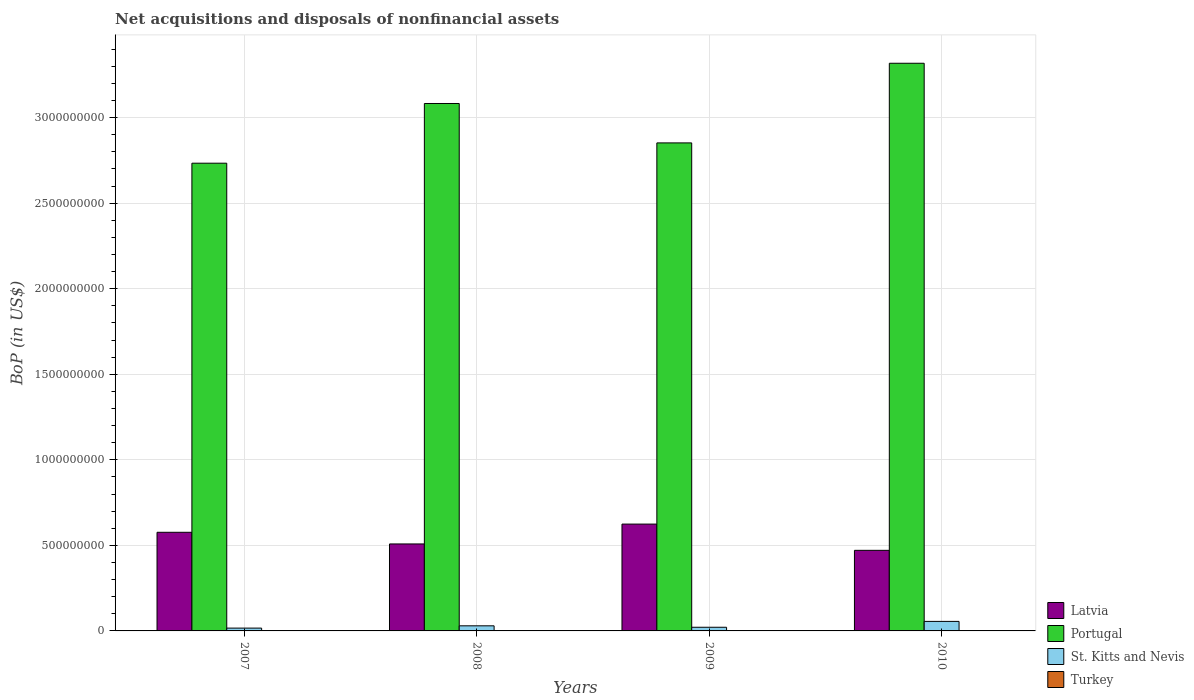How many different coloured bars are there?
Offer a terse response. 3. Are the number of bars on each tick of the X-axis equal?
Ensure brevity in your answer.  Yes. What is the label of the 2nd group of bars from the left?
Give a very brief answer. 2008. What is the Balance of Payments in Portugal in 2010?
Your answer should be compact. 3.32e+09. Across all years, what is the maximum Balance of Payments in Portugal?
Offer a terse response. 3.32e+09. Across all years, what is the minimum Balance of Payments in Portugal?
Offer a terse response. 2.73e+09. In which year was the Balance of Payments in Portugal maximum?
Give a very brief answer. 2010. What is the difference between the Balance of Payments in St. Kitts and Nevis in 2008 and that in 2010?
Offer a very short reply. -2.58e+07. What is the difference between the Balance of Payments in Portugal in 2008 and the Balance of Payments in Latvia in 2007?
Keep it short and to the point. 2.51e+09. What is the average Balance of Payments in St. Kitts and Nevis per year?
Your response must be concise. 3.08e+07. In the year 2010, what is the difference between the Balance of Payments in Portugal and Balance of Payments in Latvia?
Provide a succinct answer. 2.85e+09. In how many years, is the Balance of Payments in Latvia greater than 1500000000 US$?
Ensure brevity in your answer.  0. What is the ratio of the Balance of Payments in St. Kitts and Nevis in 2007 to that in 2010?
Offer a terse response. 0.3. What is the difference between the highest and the second highest Balance of Payments in Latvia?
Provide a succinct answer. 4.79e+07. What is the difference between the highest and the lowest Balance of Payments in Latvia?
Keep it short and to the point. 1.53e+08. Is the sum of the Balance of Payments in St. Kitts and Nevis in 2007 and 2008 greater than the maximum Balance of Payments in Portugal across all years?
Make the answer very short. No. Are all the bars in the graph horizontal?
Offer a terse response. No. How many years are there in the graph?
Your response must be concise. 4. Does the graph contain any zero values?
Provide a short and direct response. Yes. Does the graph contain grids?
Make the answer very short. Yes. Where does the legend appear in the graph?
Your answer should be very brief. Bottom right. How are the legend labels stacked?
Provide a succinct answer. Vertical. What is the title of the graph?
Keep it short and to the point. Net acquisitions and disposals of nonfinancial assets. Does "Mauritius" appear as one of the legend labels in the graph?
Provide a succinct answer. No. What is the label or title of the X-axis?
Make the answer very short. Years. What is the label or title of the Y-axis?
Ensure brevity in your answer.  BoP (in US$). What is the BoP (in US$) of Latvia in 2007?
Offer a very short reply. 5.77e+08. What is the BoP (in US$) of Portugal in 2007?
Your answer should be compact. 2.73e+09. What is the BoP (in US$) in St. Kitts and Nevis in 2007?
Keep it short and to the point. 1.64e+07. What is the BoP (in US$) in Turkey in 2007?
Offer a terse response. 0. What is the BoP (in US$) in Latvia in 2008?
Give a very brief answer. 5.08e+08. What is the BoP (in US$) in Portugal in 2008?
Your answer should be compact. 3.08e+09. What is the BoP (in US$) of St. Kitts and Nevis in 2008?
Give a very brief answer. 2.98e+07. What is the BoP (in US$) in Turkey in 2008?
Your answer should be very brief. 0. What is the BoP (in US$) in Latvia in 2009?
Keep it short and to the point. 6.24e+08. What is the BoP (in US$) in Portugal in 2009?
Give a very brief answer. 2.85e+09. What is the BoP (in US$) in St. Kitts and Nevis in 2009?
Offer a very short reply. 2.14e+07. What is the BoP (in US$) in Latvia in 2010?
Provide a succinct answer. 4.71e+08. What is the BoP (in US$) of Portugal in 2010?
Ensure brevity in your answer.  3.32e+09. What is the BoP (in US$) of St. Kitts and Nevis in 2010?
Your response must be concise. 5.56e+07. What is the BoP (in US$) in Turkey in 2010?
Make the answer very short. 0. Across all years, what is the maximum BoP (in US$) of Latvia?
Ensure brevity in your answer.  6.24e+08. Across all years, what is the maximum BoP (in US$) of Portugal?
Your answer should be very brief. 3.32e+09. Across all years, what is the maximum BoP (in US$) in St. Kitts and Nevis?
Ensure brevity in your answer.  5.56e+07. Across all years, what is the minimum BoP (in US$) of Latvia?
Provide a short and direct response. 4.71e+08. Across all years, what is the minimum BoP (in US$) of Portugal?
Give a very brief answer. 2.73e+09. Across all years, what is the minimum BoP (in US$) in St. Kitts and Nevis?
Give a very brief answer. 1.64e+07. What is the total BoP (in US$) of Latvia in the graph?
Make the answer very short. 2.18e+09. What is the total BoP (in US$) in Portugal in the graph?
Keep it short and to the point. 1.20e+1. What is the total BoP (in US$) of St. Kitts and Nevis in the graph?
Offer a very short reply. 1.23e+08. What is the difference between the BoP (in US$) in Latvia in 2007 and that in 2008?
Offer a very short reply. 6.82e+07. What is the difference between the BoP (in US$) in Portugal in 2007 and that in 2008?
Your answer should be very brief. -3.49e+08. What is the difference between the BoP (in US$) of St. Kitts and Nevis in 2007 and that in 2008?
Ensure brevity in your answer.  -1.34e+07. What is the difference between the BoP (in US$) in Latvia in 2007 and that in 2009?
Provide a short and direct response. -4.79e+07. What is the difference between the BoP (in US$) in Portugal in 2007 and that in 2009?
Keep it short and to the point. -1.19e+08. What is the difference between the BoP (in US$) in St. Kitts and Nevis in 2007 and that in 2009?
Give a very brief answer. -4.94e+06. What is the difference between the BoP (in US$) in Latvia in 2007 and that in 2010?
Provide a succinct answer. 1.06e+08. What is the difference between the BoP (in US$) in Portugal in 2007 and that in 2010?
Offer a terse response. -5.84e+08. What is the difference between the BoP (in US$) of St. Kitts and Nevis in 2007 and that in 2010?
Your answer should be very brief. -3.92e+07. What is the difference between the BoP (in US$) of Latvia in 2008 and that in 2009?
Provide a succinct answer. -1.16e+08. What is the difference between the BoP (in US$) of Portugal in 2008 and that in 2009?
Provide a succinct answer. 2.30e+08. What is the difference between the BoP (in US$) of St. Kitts and Nevis in 2008 and that in 2009?
Your answer should be compact. 8.42e+06. What is the difference between the BoP (in US$) of Latvia in 2008 and that in 2010?
Your answer should be compact. 3.74e+07. What is the difference between the BoP (in US$) in Portugal in 2008 and that in 2010?
Your answer should be very brief. -2.35e+08. What is the difference between the BoP (in US$) in St. Kitts and Nevis in 2008 and that in 2010?
Your answer should be compact. -2.58e+07. What is the difference between the BoP (in US$) of Latvia in 2009 and that in 2010?
Provide a short and direct response. 1.53e+08. What is the difference between the BoP (in US$) of Portugal in 2009 and that in 2010?
Your answer should be very brief. -4.66e+08. What is the difference between the BoP (in US$) in St. Kitts and Nevis in 2009 and that in 2010?
Make the answer very short. -3.43e+07. What is the difference between the BoP (in US$) of Latvia in 2007 and the BoP (in US$) of Portugal in 2008?
Provide a short and direct response. -2.51e+09. What is the difference between the BoP (in US$) in Latvia in 2007 and the BoP (in US$) in St. Kitts and Nevis in 2008?
Your answer should be compact. 5.47e+08. What is the difference between the BoP (in US$) in Portugal in 2007 and the BoP (in US$) in St. Kitts and Nevis in 2008?
Your answer should be compact. 2.70e+09. What is the difference between the BoP (in US$) of Latvia in 2007 and the BoP (in US$) of Portugal in 2009?
Your response must be concise. -2.28e+09. What is the difference between the BoP (in US$) of Latvia in 2007 and the BoP (in US$) of St. Kitts and Nevis in 2009?
Provide a short and direct response. 5.55e+08. What is the difference between the BoP (in US$) of Portugal in 2007 and the BoP (in US$) of St. Kitts and Nevis in 2009?
Provide a short and direct response. 2.71e+09. What is the difference between the BoP (in US$) of Latvia in 2007 and the BoP (in US$) of Portugal in 2010?
Keep it short and to the point. -2.74e+09. What is the difference between the BoP (in US$) of Latvia in 2007 and the BoP (in US$) of St. Kitts and Nevis in 2010?
Provide a short and direct response. 5.21e+08. What is the difference between the BoP (in US$) in Portugal in 2007 and the BoP (in US$) in St. Kitts and Nevis in 2010?
Ensure brevity in your answer.  2.68e+09. What is the difference between the BoP (in US$) of Latvia in 2008 and the BoP (in US$) of Portugal in 2009?
Your answer should be very brief. -2.34e+09. What is the difference between the BoP (in US$) in Latvia in 2008 and the BoP (in US$) in St. Kitts and Nevis in 2009?
Give a very brief answer. 4.87e+08. What is the difference between the BoP (in US$) in Portugal in 2008 and the BoP (in US$) in St. Kitts and Nevis in 2009?
Give a very brief answer. 3.06e+09. What is the difference between the BoP (in US$) in Latvia in 2008 and the BoP (in US$) in Portugal in 2010?
Give a very brief answer. -2.81e+09. What is the difference between the BoP (in US$) of Latvia in 2008 and the BoP (in US$) of St. Kitts and Nevis in 2010?
Make the answer very short. 4.53e+08. What is the difference between the BoP (in US$) in Portugal in 2008 and the BoP (in US$) in St. Kitts and Nevis in 2010?
Offer a terse response. 3.03e+09. What is the difference between the BoP (in US$) of Latvia in 2009 and the BoP (in US$) of Portugal in 2010?
Your response must be concise. -2.69e+09. What is the difference between the BoP (in US$) of Latvia in 2009 and the BoP (in US$) of St. Kitts and Nevis in 2010?
Offer a terse response. 5.69e+08. What is the difference between the BoP (in US$) in Portugal in 2009 and the BoP (in US$) in St. Kitts and Nevis in 2010?
Your answer should be very brief. 2.80e+09. What is the average BoP (in US$) in Latvia per year?
Keep it short and to the point. 5.45e+08. What is the average BoP (in US$) in Portugal per year?
Provide a succinct answer. 3.00e+09. What is the average BoP (in US$) of St. Kitts and Nevis per year?
Offer a very short reply. 3.08e+07. What is the average BoP (in US$) of Turkey per year?
Your answer should be very brief. 0. In the year 2007, what is the difference between the BoP (in US$) in Latvia and BoP (in US$) in Portugal?
Make the answer very short. -2.16e+09. In the year 2007, what is the difference between the BoP (in US$) in Latvia and BoP (in US$) in St. Kitts and Nevis?
Your answer should be very brief. 5.60e+08. In the year 2007, what is the difference between the BoP (in US$) of Portugal and BoP (in US$) of St. Kitts and Nevis?
Make the answer very short. 2.72e+09. In the year 2008, what is the difference between the BoP (in US$) of Latvia and BoP (in US$) of Portugal?
Your response must be concise. -2.57e+09. In the year 2008, what is the difference between the BoP (in US$) of Latvia and BoP (in US$) of St. Kitts and Nevis?
Your answer should be very brief. 4.79e+08. In the year 2008, what is the difference between the BoP (in US$) of Portugal and BoP (in US$) of St. Kitts and Nevis?
Your answer should be compact. 3.05e+09. In the year 2009, what is the difference between the BoP (in US$) in Latvia and BoP (in US$) in Portugal?
Make the answer very short. -2.23e+09. In the year 2009, what is the difference between the BoP (in US$) of Latvia and BoP (in US$) of St. Kitts and Nevis?
Make the answer very short. 6.03e+08. In the year 2009, what is the difference between the BoP (in US$) in Portugal and BoP (in US$) in St. Kitts and Nevis?
Offer a terse response. 2.83e+09. In the year 2010, what is the difference between the BoP (in US$) of Latvia and BoP (in US$) of Portugal?
Offer a terse response. -2.85e+09. In the year 2010, what is the difference between the BoP (in US$) in Latvia and BoP (in US$) in St. Kitts and Nevis?
Provide a succinct answer. 4.15e+08. In the year 2010, what is the difference between the BoP (in US$) in Portugal and BoP (in US$) in St. Kitts and Nevis?
Ensure brevity in your answer.  3.26e+09. What is the ratio of the BoP (in US$) of Latvia in 2007 to that in 2008?
Make the answer very short. 1.13. What is the ratio of the BoP (in US$) in Portugal in 2007 to that in 2008?
Your response must be concise. 0.89. What is the ratio of the BoP (in US$) of St. Kitts and Nevis in 2007 to that in 2008?
Make the answer very short. 0.55. What is the ratio of the BoP (in US$) in Latvia in 2007 to that in 2009?
Your answer should be compact. 0.92. What is the ratio of the BoP (in US$) in Portugal in 2007 to that in 2009?
Provide a succinct answer. 0.96. What is the ratio of the BoP (in US$) of St. Kitts and Nevis in 2007 to that in 2009?
Offer a terse response. 0.77. What is the ratio of the BoP (in US$) of Latvia in 2007 to that in 2010?
Your answer should be compact. 1.22. What is the ratio of the BoP (in US$) of Portugal in 2007 to that in 2010?
Keep it short and to the point. 0.82. What is the ratio of the BoP (in US$) of St. Kitts and Nevis in 2007 to that in 2010?
Offer a very short reply. 0.3. What is the ratio of the BoP (in US$) in Latvia in 2008 to that in 2009?
Give a very brief answer. 0.81. What is the ratio of the BoP (in US$) of Portugal in 2008 to that in 2009?
Give a very brief answer. 1.08. What is the ratio of the BoP (in US$) of St. Kitts and Nevis in 2008 to that in 2009?
Ensure brevity in your answer.  1.39. What is the ratio of the BoP (in US$) in Latvia in 2008 to that in 2010?
Provide a short and direct response. 1.08. What is the ratio of the BoP (in US$) in Portugal in 2008 to that in 2010?
Your answer should be compact. 0.93. What is the ratio of the BoP (in US$) of St. Kitts and Nevis in 2008 to that in 2010?
Your answer should be compact. 0.54. What is the ratio of the BoP (in US$) of Latvia in 2009 to that in 2010?
Provide a succinct answer. 1.33. What is the ratio of the BoP (in US$) of Portugal in 2009 to that in 2010?
Your answer should be compact. 0.86. What is the ratio of the BoP (in US$) of St. Kitts and Nevis in 2009 to that in 2010?
Provide a short and direct response. 0.38. What is the difference between the highest and the second highest BoP (in US$) in Latvia?
Your answer should be very brief. 4.79e+07. What is the difference between the highest and the second highest BoP (in US$) of Portugal?
Keep it short and to the point. 2.35e+08. What is the difference between the highest and the second highest BoP (in US$) in St. Kitts and Nevis?
Your answer should be compact. 2.58e+07. What is the difference between the highest and the lowest BoP (in US$) in Latvia?
Your answer should be compact. 1.53e+08. What is the difference between the highest and the lowest BoP (in US$) of Portugal?
Provide a short and direct response. 5.84e+08. What is the difference between the highest and the lowest BoP (in US$) of St. Kitts and Nevis?
Your answer should be compact. 3.92e+07. 